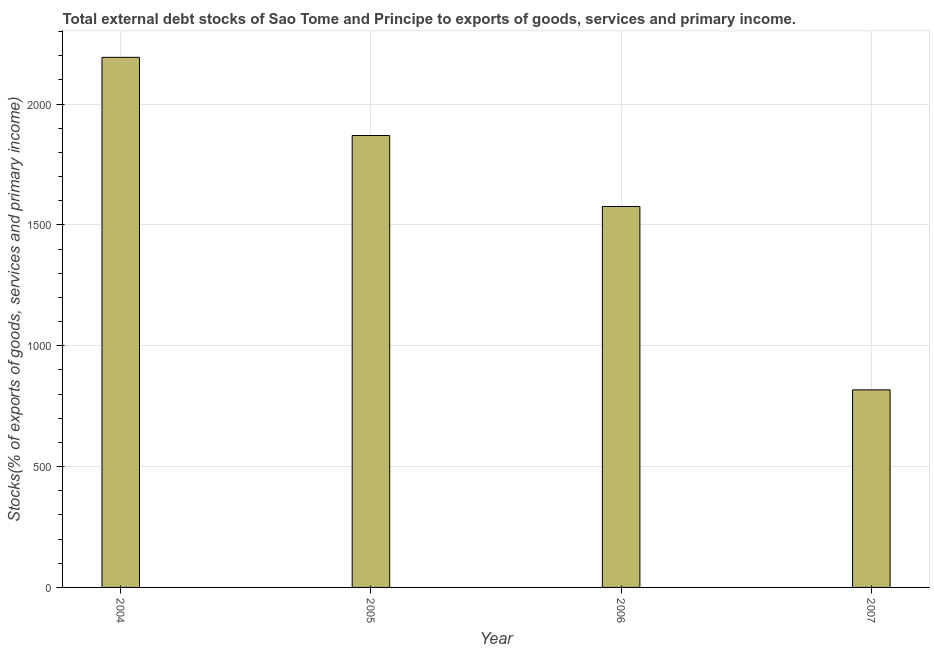What is the title of the graph?
Give a very brief answer. Total external debt stocks of Sao Tome and Principe to exports of goods, services and primary income. What is the label or title of the Y-axis?
Your answer should be compact. Stocks(% of exports of goods, services and primary income). What is the external debt stocks in 2006?
Make the answer very short. 1576.51. Across all years, what is the maximum external debt stocks?
Offer a terse response. 2193.6. Across all years, what is the minimum external debt stocks?
Give a very brief answer. 817.59. In which year was the external debt stocks maximum?
Make the answer very short. 2004. In which year was the external debt stocks minimum?
Ensure brevity in your answer.  2007. What is the sum of the external debt stocks?
Your answer should be compact. 6457.88. What is the difference between the external debt stocks in 2004 and 2005?
Give a very brief answer. 323.43. What is the average external debt stocks per year?
Provide a short and direct response. 1614.47. What is the median external debt stocks?
Give a very brief answer. 1723.34. Do a majority of the years between 2007 and 2004 (inclusive) have external debt stocks greater than 900 %?
Make the answer very short. Yes. What is the ratio of the external debt stocks in 2004 to that in 2005?
Your response must be concise. 1.17. What is the difference between the highest and the second highest external debt stocks?
Provide a succinct answer. 323.43. What is the difference between the highest and the lowest external debt stocks?
Ensure brevity in your answer.  1376.01. In how many years, is the external debt stocks greater than the average external debt stocks taken over all years?
Offer a terse response. 2. How many bars are there?
Offer a terse response. 4. What is the difference between two consecutive major ticks on the Y-axis?
Your answer should be very brief. 500. Are the values on the major ticks of Y-axis written in scientific E-notation?
Make the answer very short. No. What is the Stocks(% of exports of goods, services and primary income) of 2004?
Your answer should be very brief. 2193.6. What is the Stocks(% of exports of goods, services and primary income) of 2005?
Keep it short and to the point. 1870.18. What is the Stocks(% of exports of goods, services and primary income) of 2006?
Your answer should be very brief. 1576.51. What is the Stocks(% of exports of goods, services and primary income) in 2007?
Offer a very short reply. 817.59. What is the difference between the Stocks(% of exports of goods, services and primary income) in 2004 and 2005?
Your answer should be compact. 323.43. What is the difference between the Stocks(% of exports of goods, services and primary income) in 2004 and 2006?
Offer a very short reply. 617.09. What is the difference between the Stocks(% of exports of goods, services and primary income) in 2004 and 2007?
Ensure brevity in your answer.  1376.01. What is the difference between the Stocks(% of exports of goods, services and primary income) in 2005 and 2006?
Provide a succinct answer. 293.67. What is the difference between the Stocks(% of exports of goods, services and primary income) in 2005 and 2007?
Ensure brevity in your answer.  1052.58. What is the difference between the Stocks(% of exports of goods, services and primary income) in 2006 and 2007?
Offer a very short reply. 758.91. What is the ratio of the Stocks(% of exports of goods, services and primary income) in 2004 to that in 2005?
Provide a short and direct response. 1.17. What is the ratio of the Stocks(% of exports of goods, services and primary income) in 2004 to that in 2006?
Your answer should be very brief. 1.39. What is the ratio of the Stocks(% of exports of goods, services and primary income) in 2004 to that in 2007?
Your response must be concise. 2.68. What is the ratio of the Stocks(% of exports of goods, services and primary income) in 2005 to that in 2006?
Your response must be concise. 1.19. What is the ratio of the Stocks(% of exports of goods, services and primary income) in 2005 to that in 2007?
Provide a short and direct response. 2.29. What is the ratio of the Stocks(% of exports of goods, services and primary income) in 2006 to that in 2007?
Make the answer very short. 1.93. 